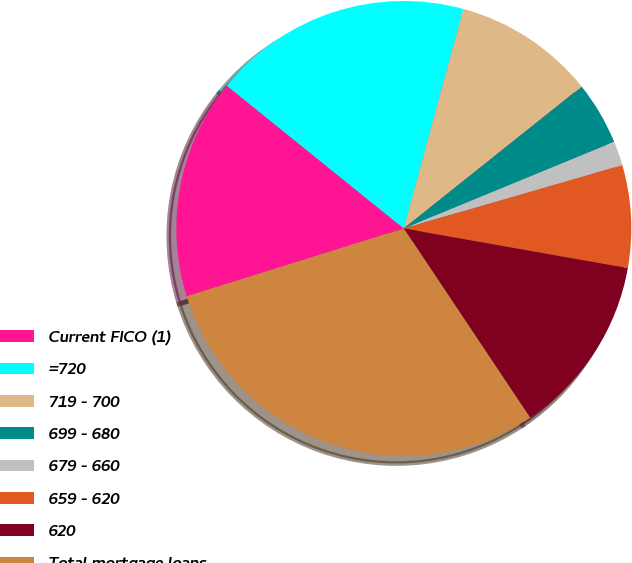Convert chart. <chart><loc_0><loc_0><loc_500><loc_500><pie_chart><fcel>Current FICO (1)<fcel>=720<fcel>719 - 700<fcel>699 - 680<fcel>679 - 660<fcel>659 - 620<fcel>620<fcel>Total mortgage loans<nl><fcel>15.63%<fcel>18.41%<fcel>10.07%<fcel>4.5%<fcel>1.72%<fcel>7.28%<fcel>12.85%<fcel>29.54%<nl></chart> 